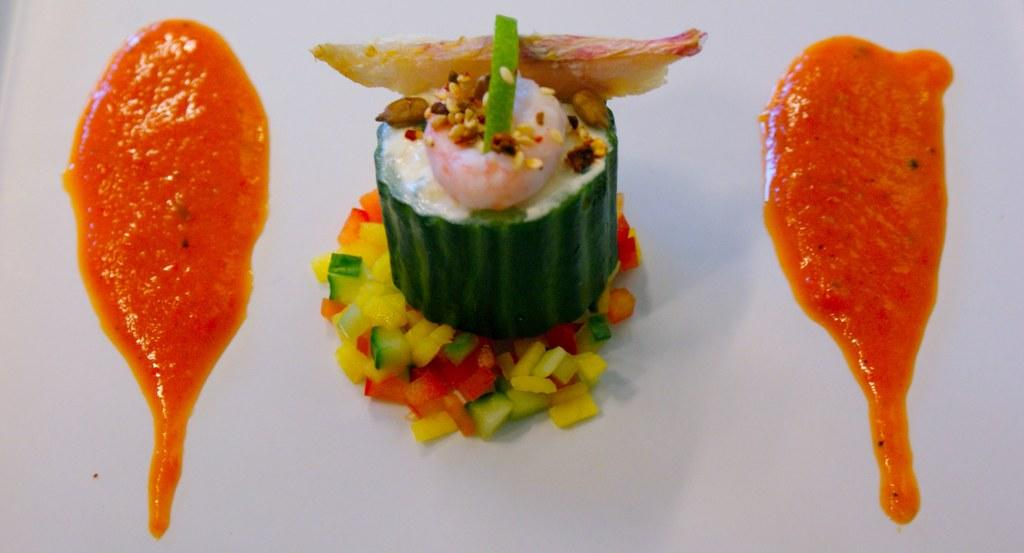What type of food can be seen in the image? There is food in the image, but the specific type cannot be determined from the provided facts. Can you describe any additional elements related to the food in the image? Yes, there is sauce in the image. What team of experts is responsible for the marble design in the image? There is no mention of a marble design or a team of experts in the image. 